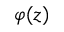Convert formula to latex. <formula><loc_0><loc_0><loc_500><loc_500>\varphi ( z )</formula> 